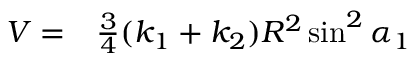<formula> <loc_0><loc_0><loc_500><loc_500>\begin{array} { r l } { V = } & \frac { 3 } { 4 } ( k _ { 1 } + k _ { 2 } ) R ^ { 2 } \sin ^ { 2 } \alpha _ { 1 } } \end{array}</formula> 